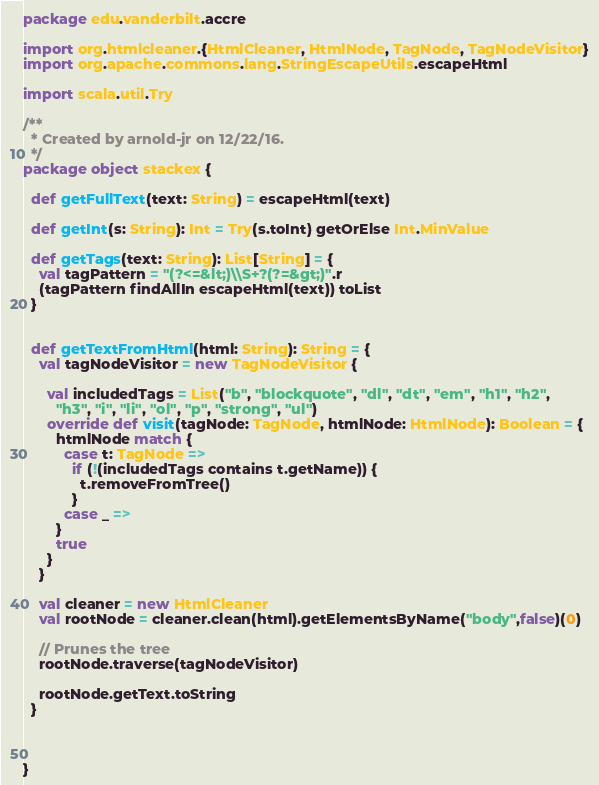<code> <loc_0><loc_0><loc_500><loc_500><_Scala_>package edu.vanderbilt.accre

import org.htmlcleaner.{HtmlCleaner, HtmlNode, TagNode, TagNodeVisitor}
import org.apache.commons.lang.StringEscapeUtils.escapeHtml

import scala.util.Try

/**
  * Created by arnold-jr on 12/22/16.
  */
package object stackex {

  def getFullText(text: String) = escapeHtml(text)

  def getInt(s: String): Int = Try(s.toInt) getOrElse Int.MinValue

  def getTags(text: String): List[String] = {
    val tagPattern = "(?<=&lt;)\\S+?(?=&gt;)".r
    (tagPattern findAllIn escapeHtml(text)) toList
  }


  def getTextFromHtml(html: String): String = {
    val tagNodeVisitor = new TagNodeVisitor {

      val includedTags = List("b", "blockquote", "dl", "dt", "em", "h1", "h2",
        "h3", "i", "li", "ol", "p", "strong", "ul")
      override def visit(tagNode: TagNode, htmlNode: HtmlNode): Boolean = {
        htmlNode match {
          case t: TagNode =>
            if (!(includedTags contains t.getName)) {
              t.removeFromTree()
            }
          case _ =>
        }
        true
      }
    }

    val cleaner = new HtmlCleaner
    val rootNode = cleaner.clean(html).getElementsByName("body",false)(0)

    // Prunes the tree
    rootNode.traverse(tagNodeVisitor)

    rootNode.getText.toString
  }



}
</code> 